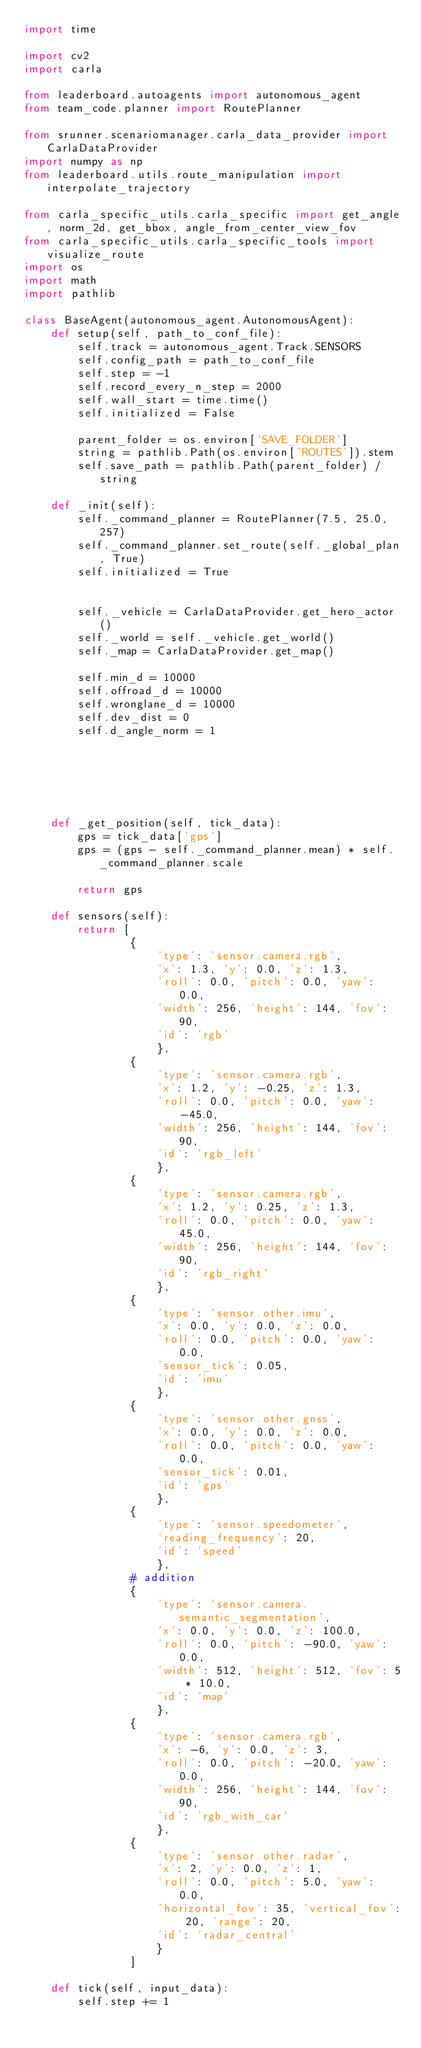Convert code to text. <code><loc_0><loc_0><loc_500><loc_500><_Python_>import time

import cv2
import carla

from leaderboard.autoagents import autonomous_agent
from team_code.planner import RoutePlanner

from srunner.scenariomanager.carla_data_provider import CarlaDataProvider
import numpy as np
from leaderboard.utils.route_manipulation import interpolate_trajectory

from carla_specific_utils.carla_specific import get_angle, norm_2d, get_bbox, angle_from_center_view_fov
from carla_specific_utils.carla_specific_tools import visualize_route
import os
import math
import pathlib

class BaseAgent(autonomous_agent.AutonomousAgent):
    def setup(self, path_to_conf_file):
        self.track = autonomous_agent.Track.SENSORS
        self.config_path = path_to_conf_file
        self.step = -1
        self.record_every_n_step = 2000
        self.wall_start = time.time()
        self.initialized = False

        parent_folder = os.environ['SAVE_FOLDER']
        string = pathlib.Path(os.environ['ROUTES']).stem
        self.save_path = pathlib.Path(parent_folder) / string

    def _init(self):
        self._command_planner = RoutePlanner(7.5, 25.0, 257)
        self._command_planner.set_route(self._global_plan, True)
        self.initialized = True


        self._vehicle = CarlaDataProvider.get_hero_actor()
        self._world = self._vehicle.get_world()
        self._map = CarlaDataProvider.get_map()

        self.min_d = 10000
        self.offroad_d = 10000
        self.wronglane_d = 10000
        self.dev_dist = 0
        self.d_angle_norm = 1






    def _get_position(self, tick_data):
        gps = tick_data['gps']
        gps = (gps - self._command_planner.mean) * self._command_planner.scale

        return gps

    def sensors(self):
        return [
                {
                    'type': 'sensor.camera.rgb',
                    'x': 1.3, 'y': 0.0, 'z': 1.3,
                    'roll': 0.0, 'pitch': 0.0, 'yaw': 0.0,
                    'width': 256, 'height': 144, 'fov': 90,
                    'id': 'rgb'
                    },
                {
                    'type': 'sensor.camera.rgb',
                    'x': 1.2, 'y': -0.25, 'z': 1.3,
                    'roll': 0.0, 'pitch': 0.0, 'yaw': -45.0,
                    'width': 256, 'height': 144, 'fov': 90,
                    'id': 'rgb_left'
                    },
                {
                    'type': 'sensor.camera.rgb',
                    'x': 1.2, 'y': 0.25, 'z': 1.3,
                    'roll': 0.0, 'pitch': 0.0, 'yaw': 45.0,
                    'width': 256, 'height': 144, 'fov': 90,
                    'id': 'rgb_right'
                    },
                {
                    'type': 'sensor.other.imu',
                    'x': 0.0, 'y': 0.0, 'z': 0.0,
                    'roll': 0.0, 'pitch': 0.0, 'yaw': 0.0,
                    'sensor_tick': 0.05,
                    'id': 'imu'
                    },
                {
                    'type': 'sensor.other.gnss',
                    'x': 0.0, 'y': 0.0, 'z': 0.0,
                    'roll': 0.0, 'pitch': 0.0, 'yaw': 0.0,
                    'sensor_tick': 0.01,
                    'id': 'gps'
                    },
                {
                    'type': 'sensor.speedometer',
                    'reading_frequency': 20,
                    'id': 'speed'
                    },
                # addition
                {
                    'type': 'sensor.camera.semantic_segmentation',
                    'x': 0.0, 'y': 0.0, 'z': 100.0,
                    'roll': 0.0, 'pitch': -90.0, 'yaw': 0.0,
                    'width': 512, 'height': 512, 'fov': 5 * 10.0,
                    'id': 'map'
                    },
                {
                    'type': 'sensor.camera.rgb',
                    'x': -6, 'y': 0.0, 'z': 3,
                    'roll': 0.0, 'pitch': -20.0, 'yaw': 0.0,
                    'width': 256, 'height': 144, 'fov': 90,
                    'id': 'rgb_with_car'
                    },
                {
                    'type': 'sensor.other.radar',
                    'x': 2, 'y': 0.0, 'z': 1,
                    'roll': 0.0, 'pitch': 5.0, 'yaw': 0.0,
                    'horizontal_fov': 35, 'vertical_fov': 20, 'range': 20,
                    'id': 'radar_central'
                    }
                ]

    def tick(self, input_data):
        self.step += 1
</code> 